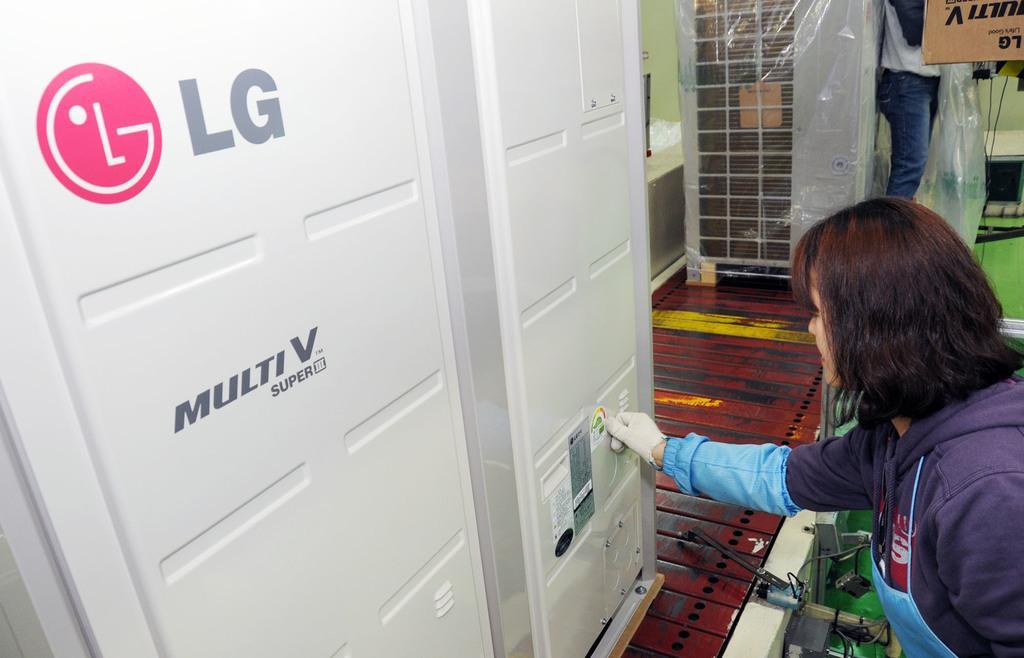Describe this image in one or two sentences. In this picture there is a woman in the foreground. At the back there is a person standing and there is a cardboard box and there is text on the box and there is an object. At the bottom there are objects. On the left side of the image there are objects and there is text and logo on the object. 